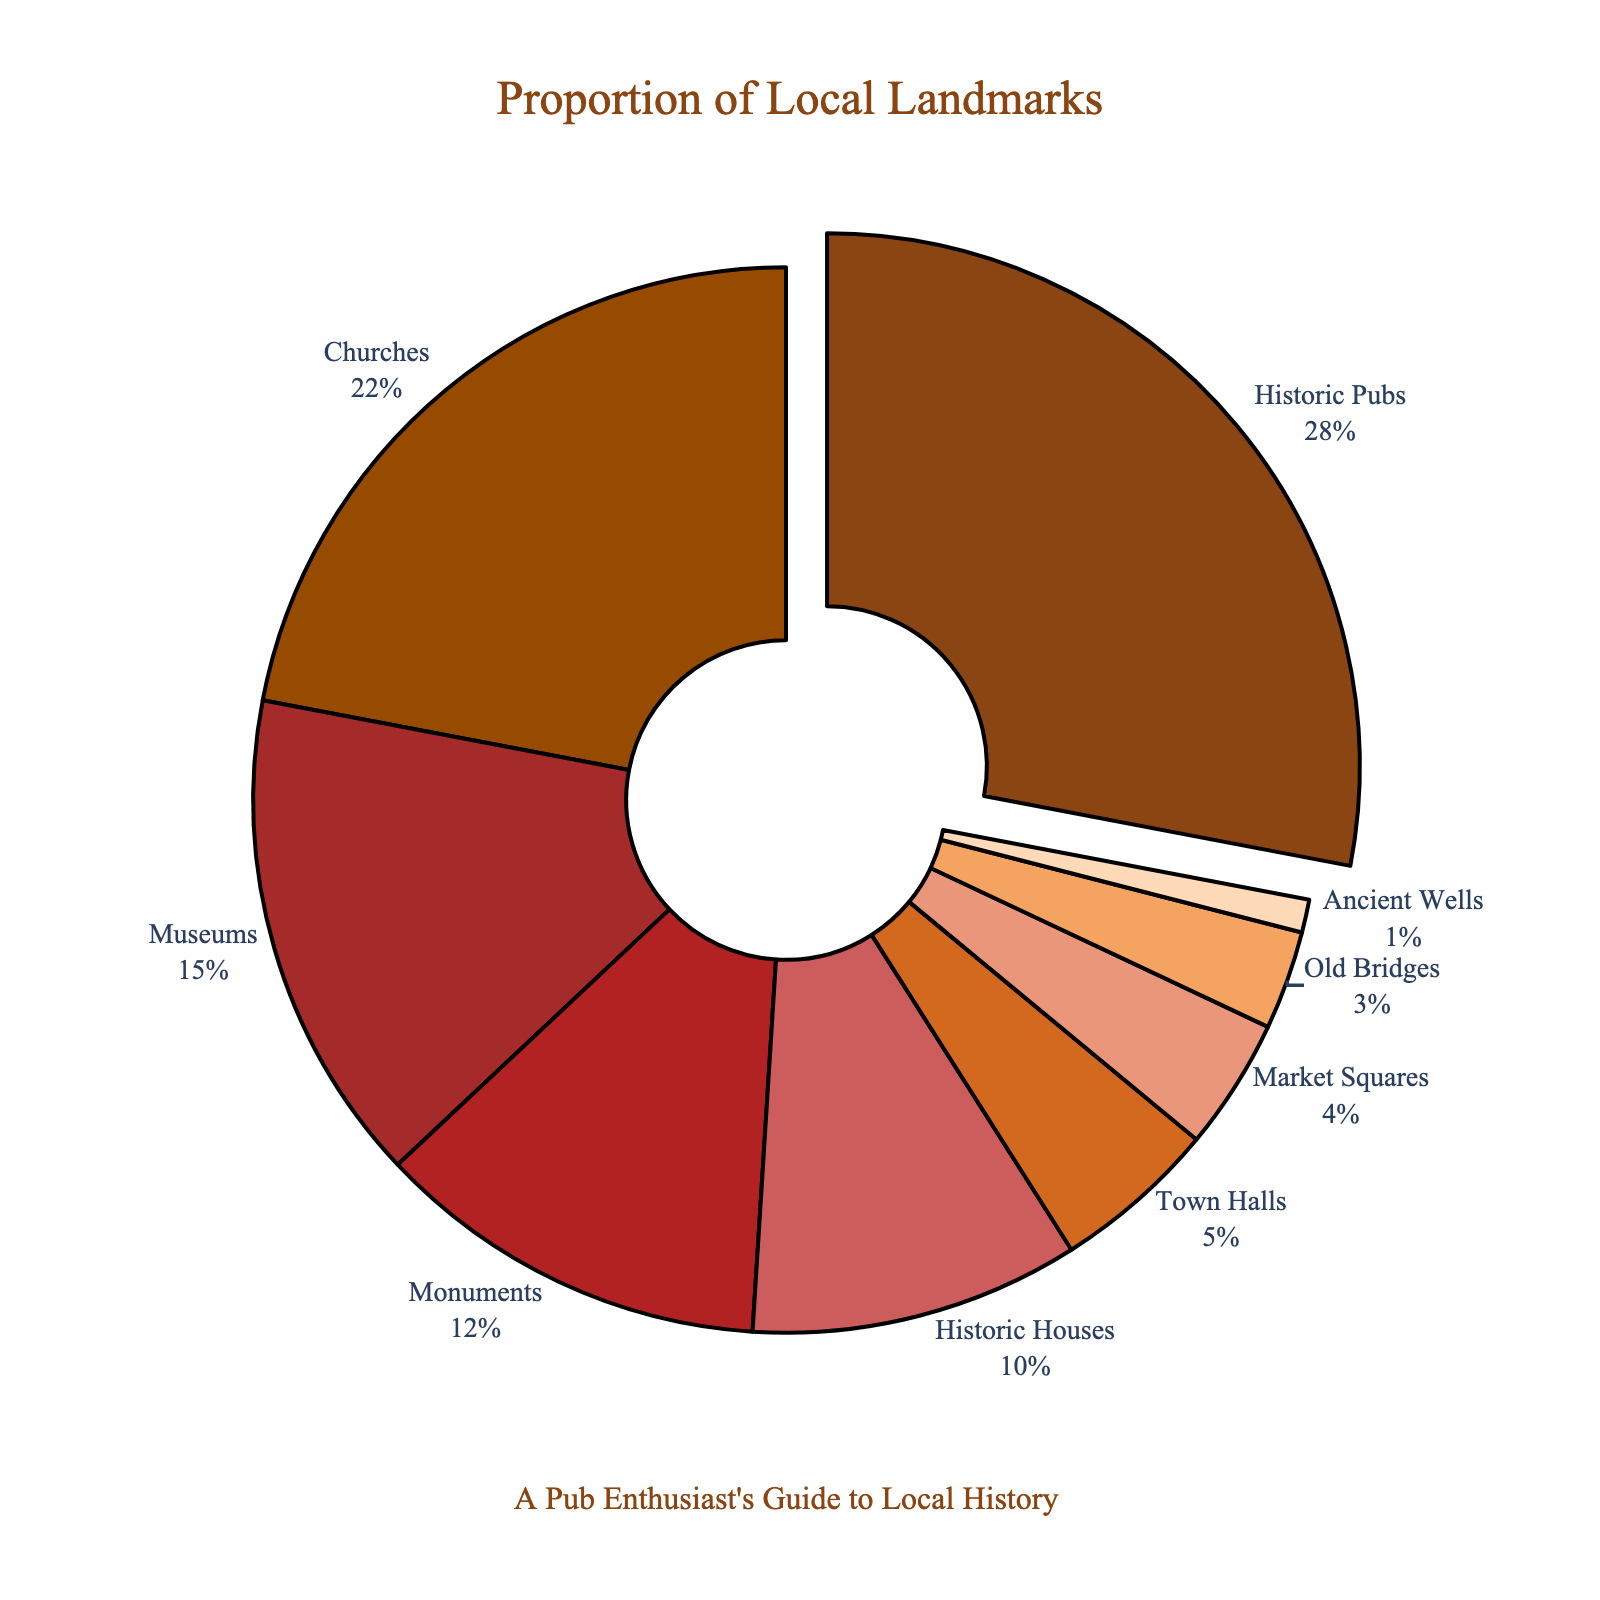Which type of local landmark has the highest proportion? The figure highlights the type with the highest proportion by slightly pulling it out from the pie chart. "Historic Pubs" are pulled out, making it the type with the highest proportion at 28%.
Answer: Historic Pubs What is the percentage difference between Monuments and Museums? Monuments have a proportion of 12%, and Museums have a proportion of 15%. The difference between them is 15% - 12% = 3%.
Answer: 3% Which types of landmarks make up more than 20% of the chart? We can see from the labels and percentages displayed that "Historic Pubs" and "Churches" each exceed 20%, with proportions of 28% and 22% respectively.
Answer: Historic Pubs, Churches What is the combined percentage of Town Halls, Market Squares, and Old Bridges? Town Halls are 5%, Market Squares are 4%, and Old Bridges are 3%. Adding these percentages together: 5% + 4% + 3% = 12%.
Answer: 12% How much more is the proportion of Historic Pubs compared to Ancient Wells? The chart shows that Historic Pubs are 28% and Ancient Wells are 1%. Subtracting these gives 28% - 1% = 27%.
Answer: 27% Which landmark category has the second smallest proportion? The categories are sorted by their proportions, and the second smallest is "Old Bridges" with a proportion of 3%.
Answer: Old Bridges How does the proportion of Historic Houses compare to Town Halls? Historic Houses have a proportion of 10%, whereas Town Halls have 5%. Therefore, Historic Houses have twice the proportion of Town Halls.
Answer: Historic Houses are twice as much as Town Halls What is the total percentage of all landmarks related to buildings (e.g., Historic Pubs, Churches, Historic Houses, Town Halls)? Adding the relevant categories: Historic Pubs (28%) + Churches (22%) + Historic Houses (10%) + Town Halls (5%) = 65%.
Answer: 65% Which landmarks have a lower proportion than Historic Houses but higher than Town Halls? The chart shows that the only category fitting this description is "Monuments" with a proportion of 12%.
Answer: Monuments 